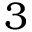Convert formula to latex. <formula><loc_0><loc_0><loc_500><loc_500>3</formula> 